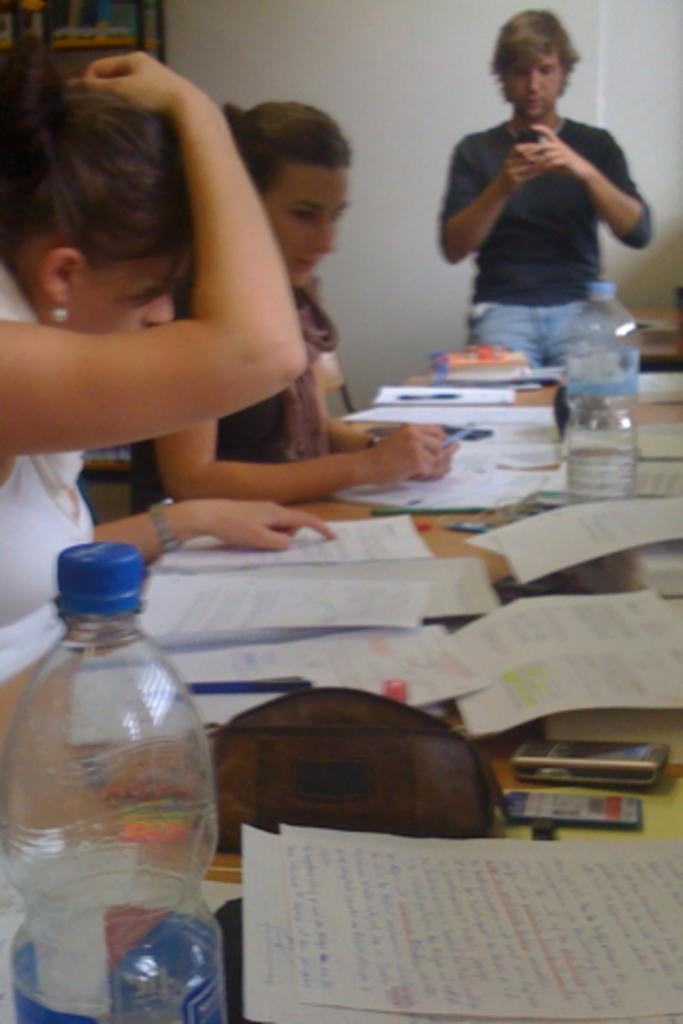How many girls are in the image? There are two girls in the image. What are the girls doing in the image? The girls are sitting in chairs and looking into books. Where is the man located in the image? The man is on the right side of the image. What type of music can be heard coming from the ear in the image? There is no ear or music present in the image. 